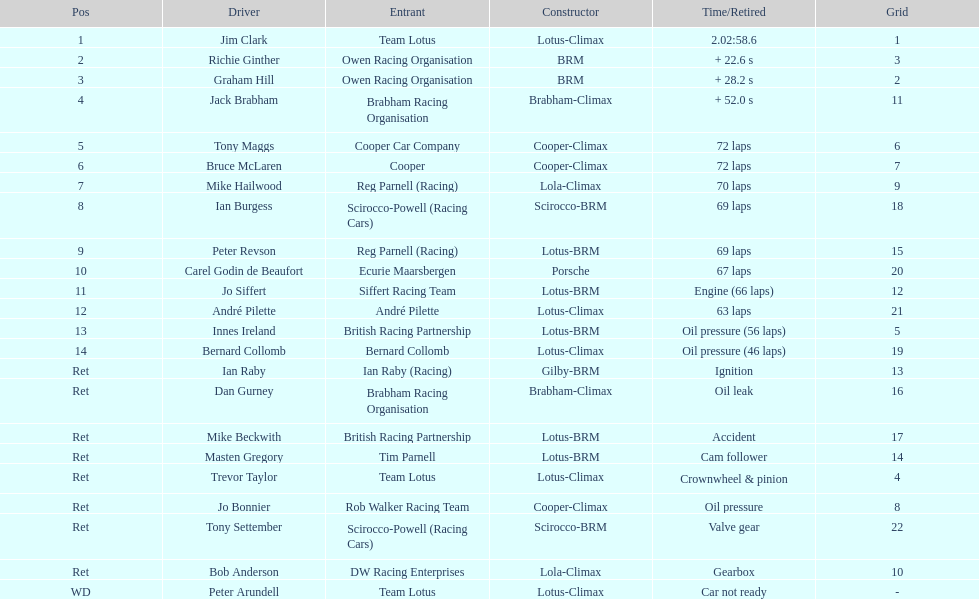How many racers had cooper-climax as their constructor? 3. 